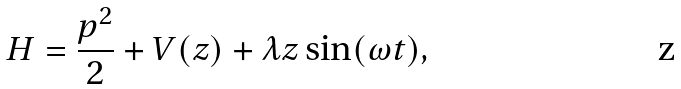<formula> <loc_0><loc_0><loc_500><loc_500>H = \frac { p ^ { 2 } } { 2 } + V ( z ) + \lambda z \sin ( \omega t ) ,</formula> 